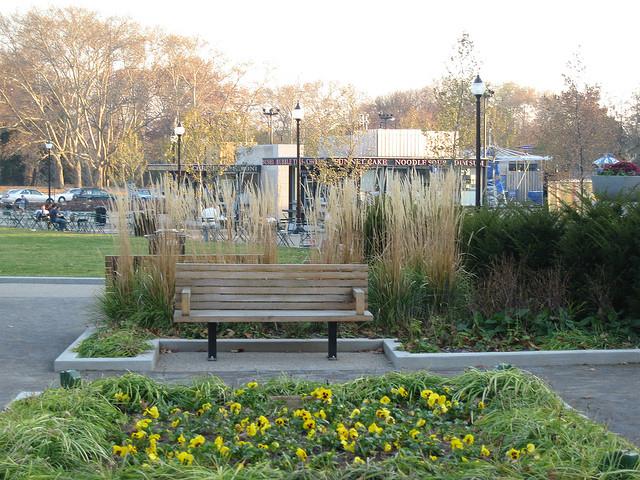Is the park nice?
Keep it brief. Yes. How many light post are there?
Quick response, please. 4. How many places are there to sit?
Write a very short answer. 2. 